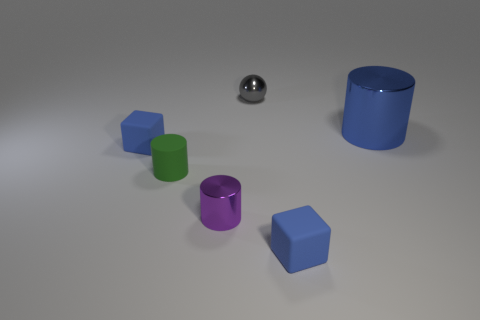What materials do the objects in the image appear to be made of? The objects in the image seem to be made from various materials. The sphere has a shiny surface, suggesting it could be metallic, while the cylinder has a matte finish, possibly indicating rubber. The cubes also exhibit matte surfaces and could be made of a plastic or painted wood. Could you tell me more about the lighting in the scene? The scene is illuminated by what appears to be soft, diffused light, likely from an overhead source. There are soft shadows under each object, suggesting the light isn't overly harsh. This type of lighting helps to reduce harsh reflections, particularly on the metallic sphere. 